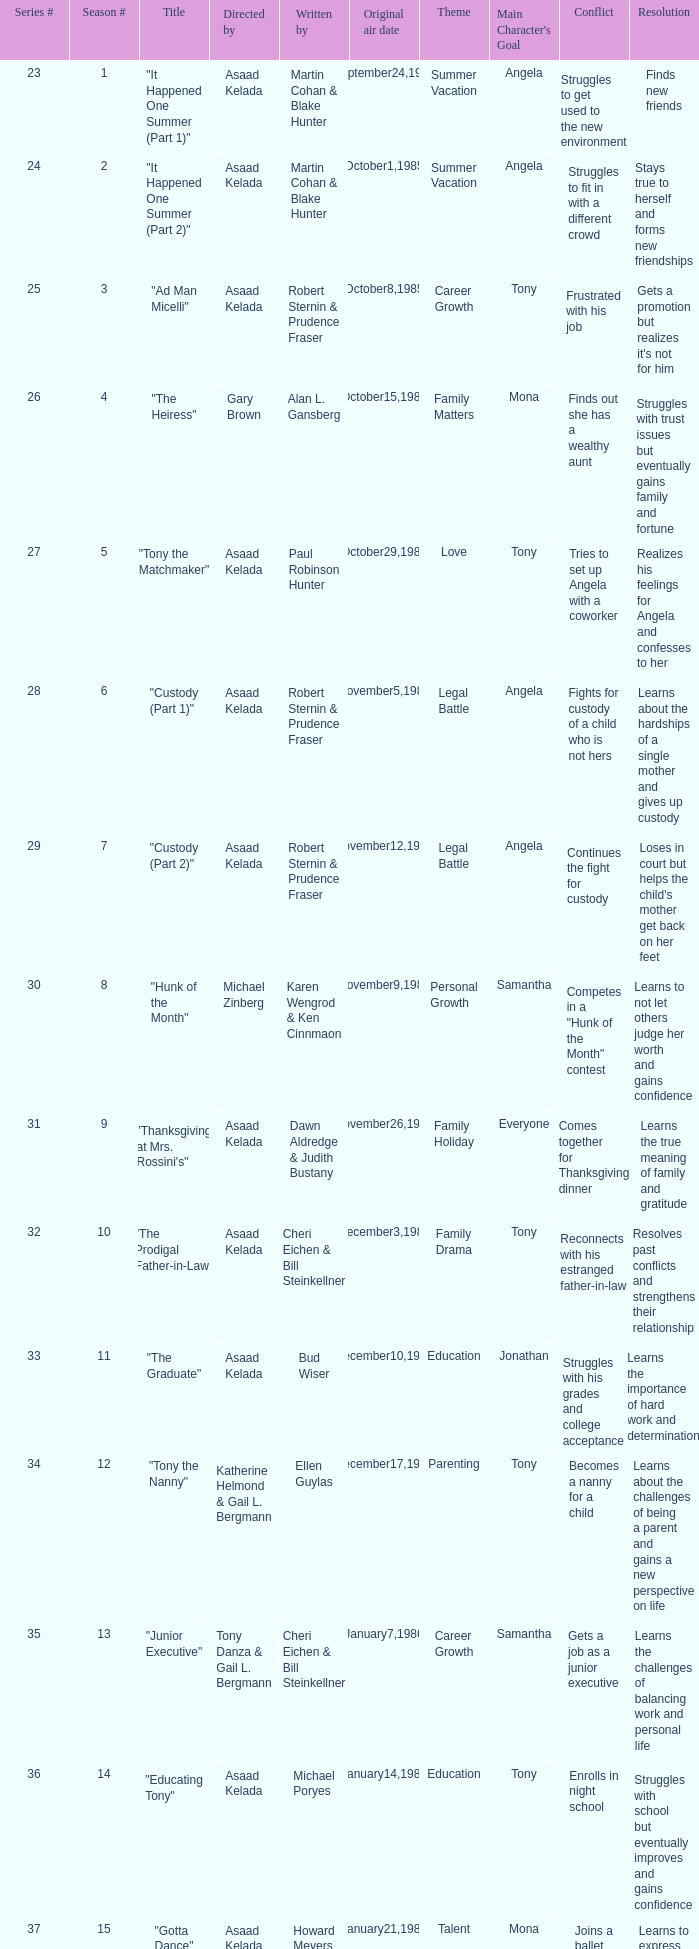What is the season where the episode "when worlds collide" was shown? 18.0. 